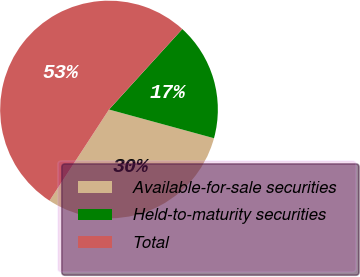<chart> <loc_0><loc_0><loc_500><loc_500><pie_chart><fcel>Available-for-sale securities<fcel>Held-to-maturity securities<fcel>Total<nl><fcel>29.95%<fcel>17.49%<fcel>52.56%<nl></chart> 